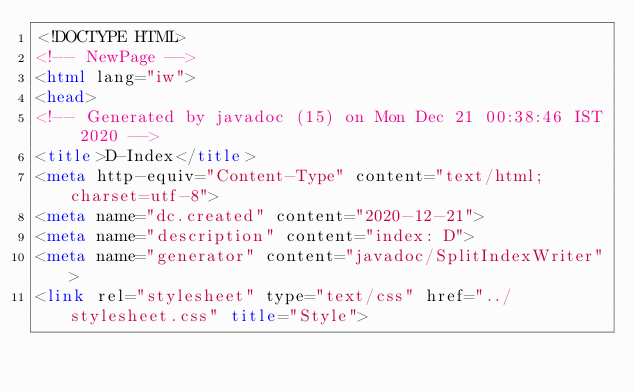Convert code to text. <code><loc_0><loc_0><loc_500><loc_500><_HTML_><!DOCTYPE HTML>
<!-- NewPage -->
<html lang="iw">
<head>
<!-- Generated by javadoc (15) on Mon Dec 21 00:38:46 IST 2020 -->
<title>D-Index</title>
<meta http-equiv="Content-Type" content="text/html; charset=utf-8">
<meta name="dc.created" content="2020-12-21">
<meta name="description" content="index: D">
<meta name="generator" content="javadoc/SplitIndexWriter">
<link rel="stylesheet" type="text/css" href="../stylesheet.css" title="Style"></code> 